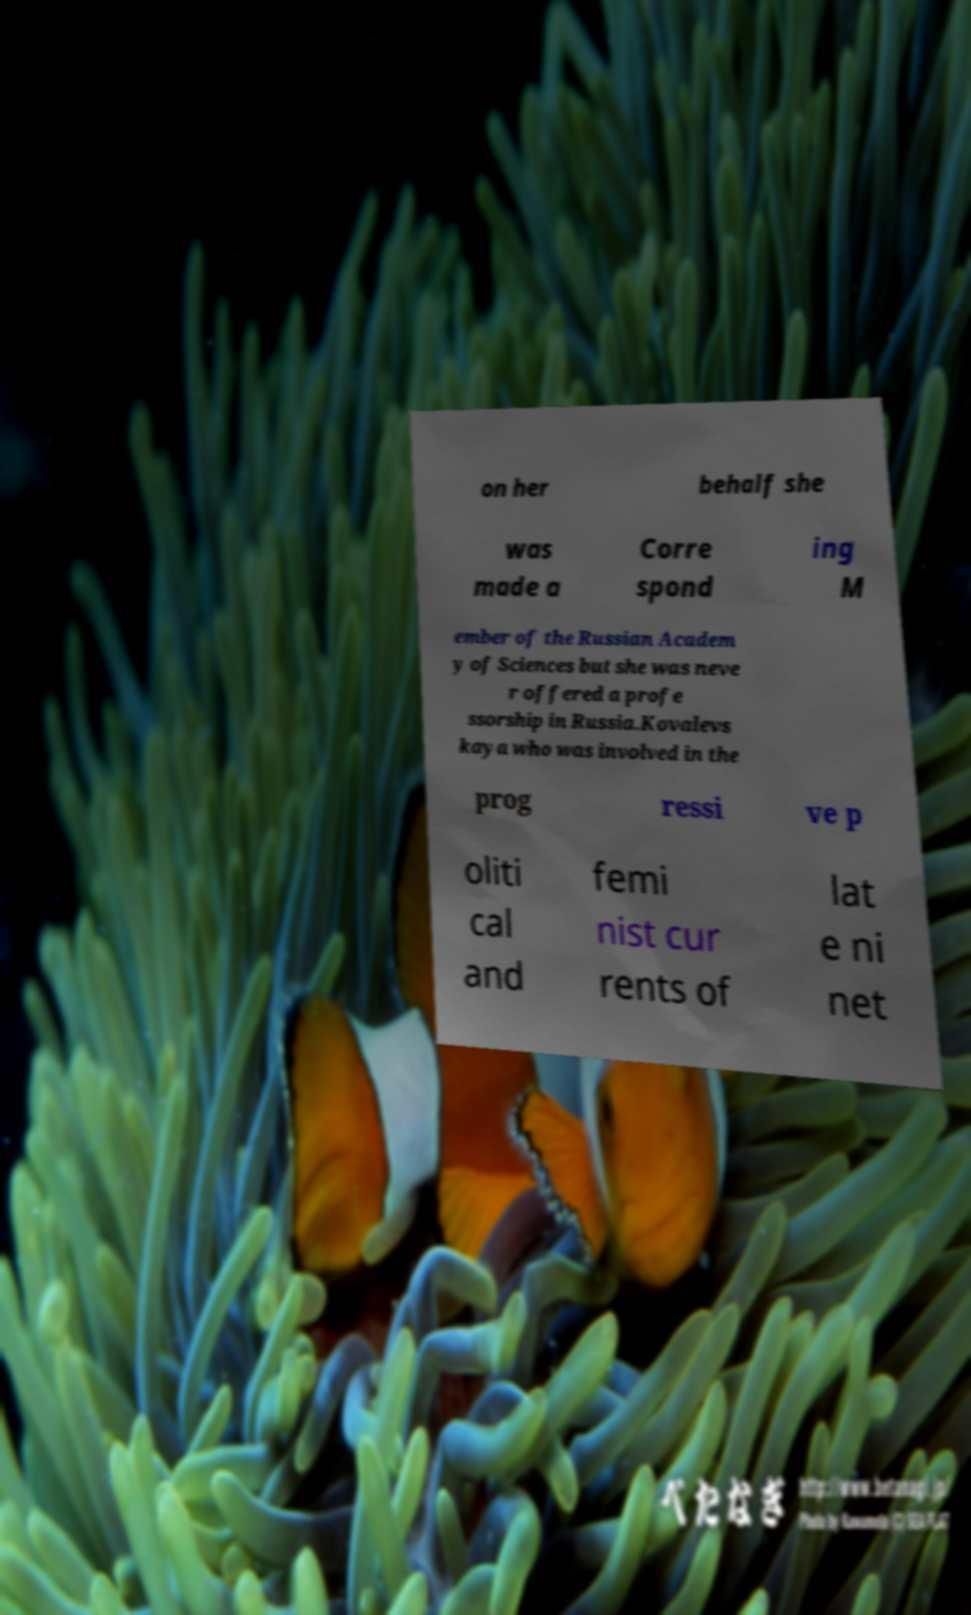Can you accurately transcribe the text from the provided image for me? on her behalf she was made a Corre spond ing M ember of the Russian Academ y of Sciences but she was neve r offered a profe ssorship in Russia.Kovalevs kaya who was involved in the prog ressi ve p oliti cal and femi nist cur rents of lat e ni net 